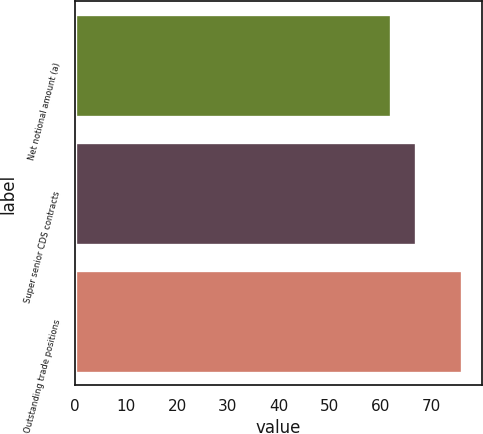<chart> <loc_0><loc_0><loc_500><loc_500><bar_chart><fcel>Net notional amount (a)<fcel>Super senior CDS contracts<fcel>Outstanding trade positions<nl><fcel>62<fcel>67<fcel>76<nl></chart> 